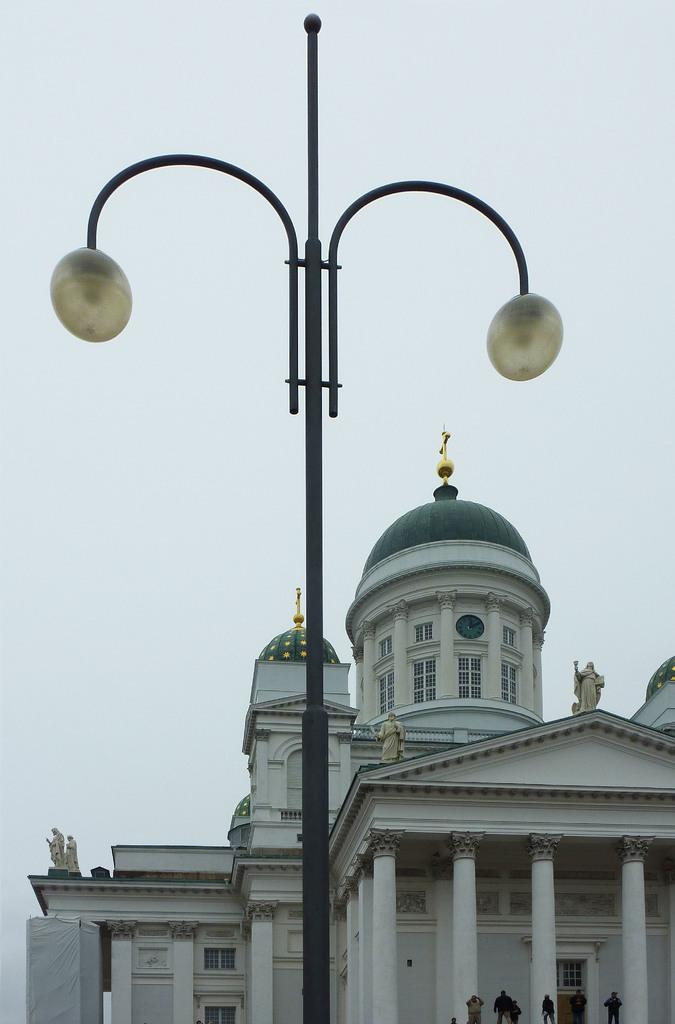What is on the pole in the image? There are lights on a pole in the image. What type of structure can be seen in the image? There is a building in the image. Where are the people located in the image? The people are at the bottom right side of the image. What can be seen in the background of the image? The sky is visible in the background of the image. What type of spark can be seen coming from the building in the image? There is no spark visible in the image; it only shows lights on a pole, a building, people, and the sky. Is there a quilt hanging on the building in the image? No, there is no quilt present in the image. 